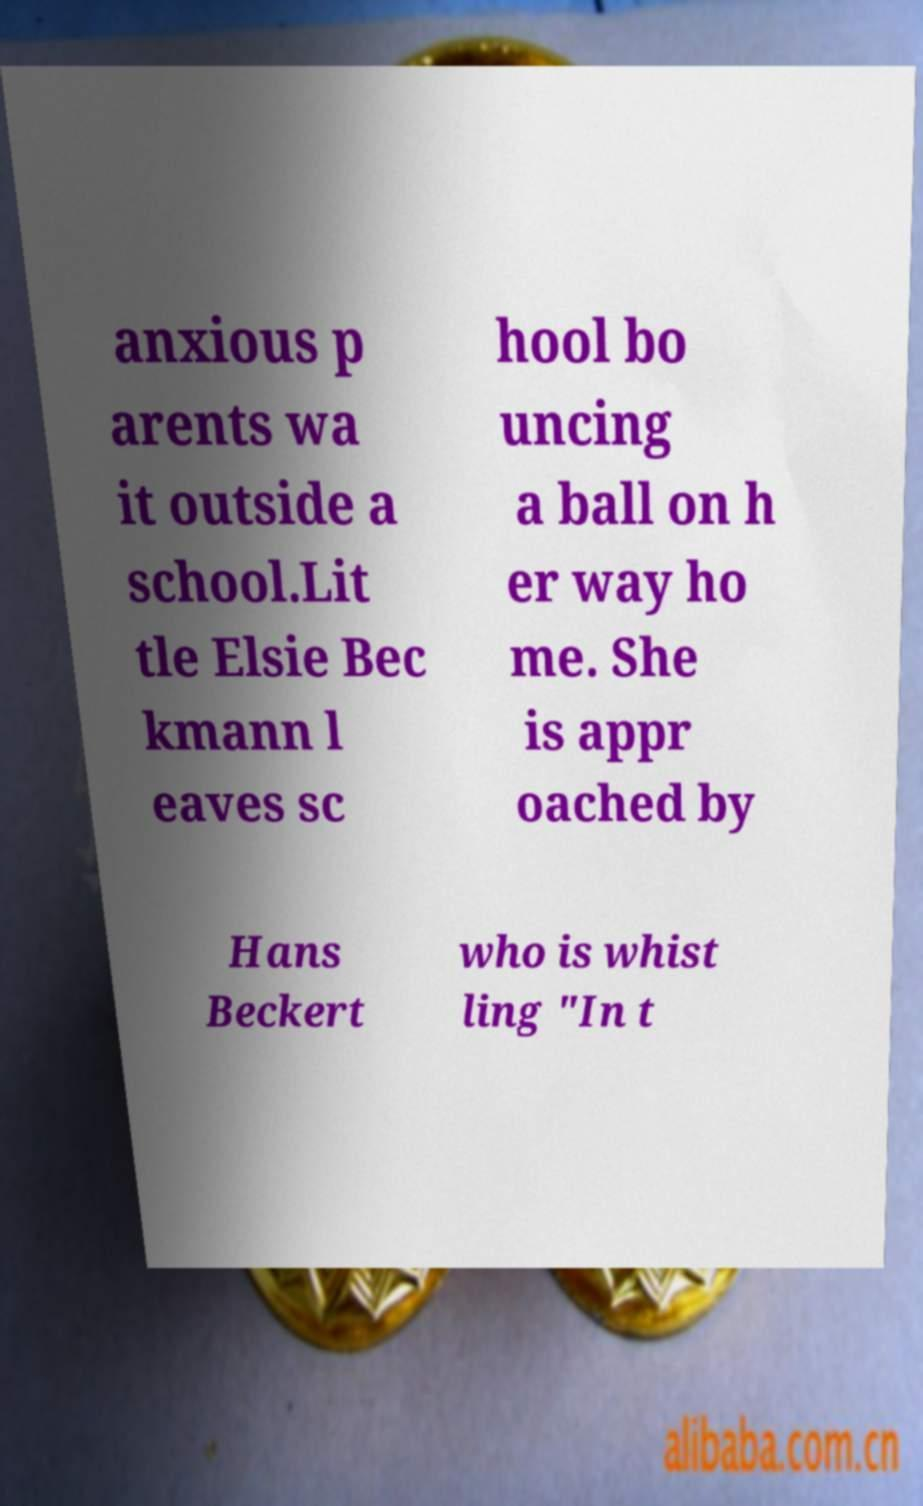For documentation purposes, I need the text within this image transcribed. Could you provide that? anxious p arents wa it outside a school.Lit tle Elsie Bec kmann l eaves sc hool bo uncing a ball on h er way ho me. She is appr oached by Hans Beckert who is whist ling "In t 